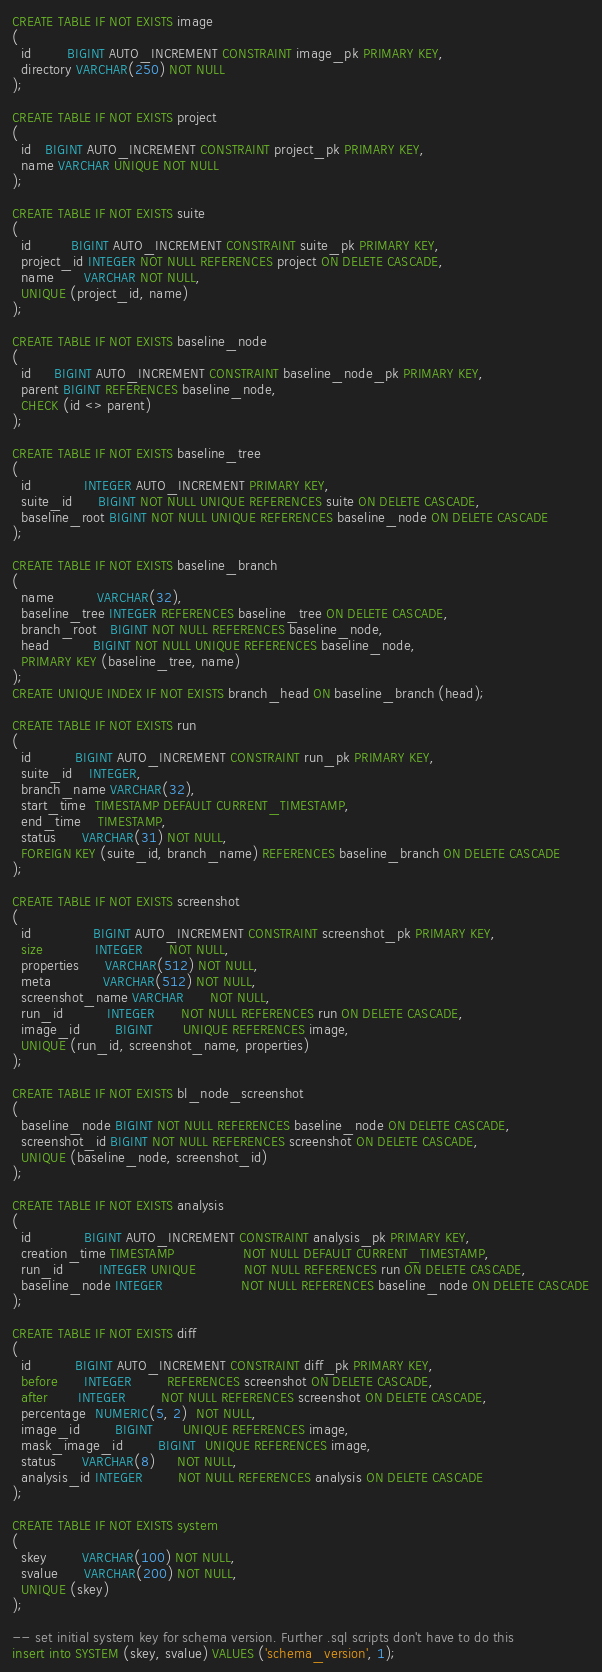<code> <loc_0><loc_0><loc_500><loc_500><_SQL_>CREATE TABLE IF NOT EXISTS image
(
  id        BIGINT AUTO_INCREMENT CONSTRAINT image_pk PRIMARY KEY,
  directory VARCHAR(250) NOT NULL
);

CREATE TABLE IF NOT EXISTS project
(
  id   BIGINT AUTO_INCREMENT CONSTRAINT project_pk PRIMARY KEY,
  name VARCHAR UNIQUE NOT NULL
);

CREATE TABLE IF NOT EXISTS suite
(
  id         BIGINT AUTO_INCREMENT CONSTRAINT suite_pk PRIMARY KEY,
  project_id INTEGER NOT NULL REFERENCES project ON DELETE CASCADE,
  name       VARCHAR NOT NULL,
  UNIQUE (project_id, name)
);

CREATE TABLE IF NOT EXISTS baseline_node
(
  id     BIGINT AUTO_INCREMENT CONSTRAINT baseline_node_pk PRIMARY KEY,
  parent BIGINT REFERENCES baseline_node,
  CHECK (id <> parent)
);

CREATE TABLE IF NOT EXISTS baseline_tree
(
  id            INTEGER AUTO_INCREMENT PRIMARY KEY,
  suite_id      BIGINT NOT NULL UNIQUE REFERENCES suite ON DELETE CASCADE,
  baseline_root BIGINT NOT NULL UNIQUE REFERENCES baseline_node ON DELETE CASCADE
);

CREATE TABLE IF NOT EXISTS baseline_branch
(
  name          VARCHAR(32),
  baseline_tree INTEGER REFERENCES baseline_tree ON DELETE CASCADE,
  branch_root   BIGINT NOT NULL REFERENCES baseline_node,
  head          BIGINT NOT NULL UNIQUE REFERENCES baseline_node,
  PRIMARY KEY (baseline_tree, name)
);
CREATE UNIQUE INDEX IF NOT EXISTS branch_head ON baseline_branch (head);

CREATE TABLE IF NOT EXISTS run
(
  id          BIGINT AUTO_INCREMENT CONSTRAINT run_pk PRIMARY KEY,
  suite_id    INTEGER,
  branch_name VARCHAR(32),
  start_time  TIMESTAMP DEFAULT CURRENT_TIMESTAMP,
  end_time    TIMESTAMP,
  status      VARCHAR(31) NOT NULL,
  FOREIGN KEY (suite_id, branch_name) REFERENCES baseline_branch ON DELETE CASCADE
);

CREATE TABLE IF NOT EXISTS screenshot
(
  id              BIGINT AUTO_INCREMENT CONSTRAINT screenshot_pk PRIMARY KEY,
  size            INTEGER      NOT NULL,
  properties      VARCHAR(512) NOT NULL,
  meta            VARCHAR(512) NOT NULL,
  screenshot_name VARCHAR      NOT NULL,
  run_id          INTEGER      NOT NULL REFERENCES run ON DELETE CASCADE,
  image_id        BIGINT       UNIQUE REFERENCES image,
  UNIQUE (run_id, screenshot_name, properties)
);

CREATE TABLE IF NOT EXISTS bl_node_screenshot
(
  baseline_node BIGINT NOT NULL REFERENCES baseline_node ON DELETE CASCADE,
  screenshot_id BIGINT NOT NULL REFERENCES screenshot ON DELETE CASCADE,
  UNIQUE (baseline_node, screenshot_id)
);

CREATE TABLE IF NOT EXISTS analysis
(
  id            BIGINT AUTO_INCREMENT CONSTRAINT analysis_pk PRIMARY KEY,
  creation_time TIMESTAMP                NOT NULL DEFAULT CURRENT_TIMESTAMP,
  run_id        INTEGER UNIQUE           NOT NULL REFERENCES run ON DELETE CASCADE,
  baseline_node INTEGER                  NOT NULL REFERENCES baseline_node ON DELETE CASCADE
);

CREATE TABLE IF NOT EXISTS diff
(
  id          BIGINT AUTO_INCREMENT CONSTRAINT diff_pk PRIMARY KEY,
  before      INTEGER        REFERENCES screenshot ON DELETE CASCADE,
  after       INTEGER        NOT NULL REFERENCES screenshot ON DELETE CASCADE,
  percentage  NUMERIC(5, 2)  NOT NULL,
  image_id        BIGINT       UNIQUE REFERENCES image,
  mask_image_id        BIGINT  UNIQUE REFERENCES image,
  status      VARCHAR(8)     NOT NULL,
  analysis_id INTEGER        NOT NULL REFERENCES analysis ON DELETE CASCADE
);

CREATE TABLE IF NOT EXISTS system
(
  skey        VARCHAR(100) NOT NULL,
  svalue      VARCHAR(200) NOT NULL,
  UNIQUE (skey)
);

-- set initial system key for schema version. Further .sql scripts don't have to do this
insert into SYSTEM (skey, svalue) VALUES ('schema_version', 1);
</code> 